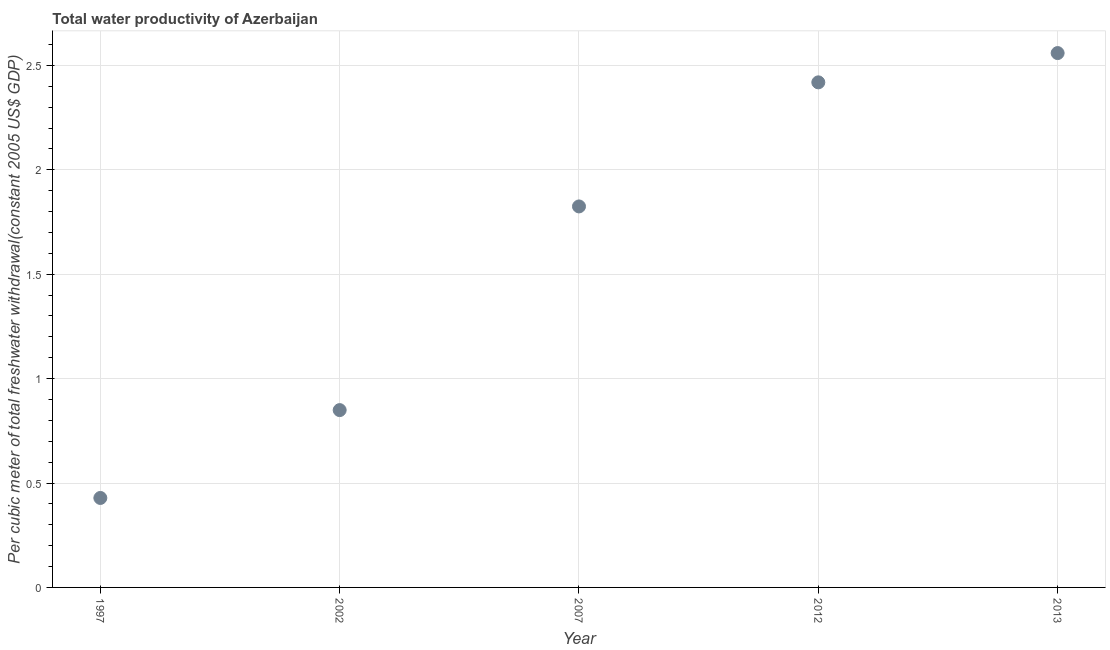What is the total water productivity in 2002?
Make the answer very short. 0.85. Across all years, what is the maximum total water productivity?
Offer a very short reply. 2.56. Across all years, what is the minimum total water productivity?
Ensure brevity in your answer.  0.43. In which year was the total water productivity maximum?
Your response must be concise. 2013. What is the sum of the total water productivity?
Your answer should be very brief. 8.08. What is the difference between the total water productivity in 2002 and 2007?
Your response must be concise. -0.98. What is the average total water productivity per year?
Make the answer very short. 1.62. What is the median total water productivity?
Keep it short and to the point. 1.82. In how many years, is the total water productivity greater than 1.8 US$?
Your answer should be very brief. 3. Do a majority of the years between 1997 and 2002 (inclusive) have total water productivity greater than 0.2 US$?
Provide a succinct answer. Yes. What is the ratio of the total water productivity in 2002 to that in 2012?
Ensure brevity in your answer.  0.35. Is the total water productivity in 2012 less than that in 2013?
Your response must be concise. Yes. What is the difference between the highest and the second highest total water productivity?
Offer a terse response. 0.14. What is the difference between the highest and the lowest total water productivity?
Provide a succinct answer. 2.13. In how many years, is the total water productivity greater than the average total water productivity taken over all years?
Give a very brief answer. 3. Does the total water productivity monotonically increase over the years?
Provide a short and direct response. Yes. How many years are there in the graph?
Offer a very short reply. 5. Does the graph contain any zero values?
Your answer should be very brief. No. Does the graph contain grids?
Offer a terse response. Yes. What is the title of the graph?
Make the answer very short. Total water productivity of Azerbaijan. What is the label or title of the Y-axis?
Offer a very short reply. Per cubic meter of total freshwater withdrawal(constant 2005 US$ GDP). What is the Per cubic meter of total freshwater withdrawal(constant 2005 US$ GDP) in 1997?
Keep it short and to the point. 0.43. What is the Per cubic meter of total freshwater withdrawal(constant 2005 US$ GDP) in 2002?
Keep it short and to the point. 0.85. What is the Per cubic meter of total freshwater withdrawal(constant 2005 US$ GDP) in 2007?
Ensure brevity in your answer.  1.82. What is the Per cubic meter of total freshwater withdrawal(constant 2005 US$ GDP) in 2012?
Keep it short and to the point. 2.42. What is the Per cubic meter of total freshwater withdrawal(constant 2005 US$ GDP) in 2013?
Provide a succinct answer. 2.56. What is the difference between the Per cubic meter of total freshwater withdrawal(constant 2005 US$ GDP) in 1997 and 2002?
Provide a short and direct response. -0.42. What is the difference between the Per cubic meter of total freshwater withdrawal(constant 2005 US$ GDP) in 1997 and 2007?
Offer a very short reply. -1.4. What is the difference between the Per cubic meter of total freshwater withdrawal(constant 2005 US$ GDP) in 1997 and 2012?
Offer a terse response. -1.99. What is the difference between the Per cubic meter of total freshwater withdrawal(constant 2005 US$ GDP) in 1997 and 2013?
Your answer should be very brief. -2.13. What is the difference between the Per cubic meter of total freshwater withdrawal(constant 2005 US$ GDP) in 2002 and 2007?
Offer a terse response. -0.98. What is the difference between the Per cubic meter of total freshwater withdrawal(constant 2005 US$ GDP) in 2002 and 2012?
Your response must be concise. -1.57. What is the difference between the Per cubic meter of total freshwater withdrawal(constant 2005 US$ GDP) in 2002 and 2013?
Provide a succinct answer. -1.71. What is the difference between the Per cubic meter of total freshwater withdrawal(constant 2005 US$ GDP) in 2007 and 2012?
Provide a short and direct response. -0.59. What is the difference between the Per cubic meter of total freshwater withdrawal(constant 2005 US$ GDP) in 2007 and 2013?
Your response must be concise. -0.73. What is the difference between the Per cubic meter of total freshwater withdrawal(constant 2005 US$ GDP) in 2012 and 2013?
Your answer should be compact. -0.14. What is the ratio of the Per cubic meter of total freshwater withdrawal(constant 2005 US$ GDP) in 1997 to that in 2002?
Your answer should be compact. 0.51. What is the ratio of the Per cubic meter of total freshwater withdrawal(constant 2005 US$ GDP) in 1997 to that in 2007?
Your response must be concise. 0.23. What is the ratio of the Per cubic meter of total freshwater withdrawal(constant 2005 US$ GDP) in 1997 to that in 2012?
Your answer should be very brief. 0.18. What is the ratio of the Per cubic meter of total freshwater withdrawal(constant 2005 US$ GDP) in 1997 to that in 2013?
Ensure brevity in your answer.  0.17. What is the ratio of the Per cubic meter of total freshwater withdrawal(constant 2005 US$ GDP) in 2002 to that in 2007?
Make the answer very short. 0.47. What is the ratio of the Per cubic meter of total freshwater withdrawal(constant 2005 US$ GDP) in 2002 to that in 2012?
Your answer should be compact. 0.35. What is the ratio of the Per cubic meter of total freshwater withdrawal(constant 2005 US$ GDP) in 2002 to that in 2013?
Provide a succinct answer. 0.33. What is the ratio of the Per cubic meter of total freshwater withdrawal(constant 2005 US$ GDP) in 2007 to that in 2012?
Ensure brevity in your answer.  0.75. What is the ratio of the Per cubic meter of total freshwater withdrawal(constant 2005 US$ GDP) in 2007 to that in 2013?
Your response must be concise. 0.71. What is the ratio of the Per cubic meter of total freshwater withdrawal(constant 2005 US$ GDP) in 2012 to that in 2013?
Provide a succinct answer. 0.94. 